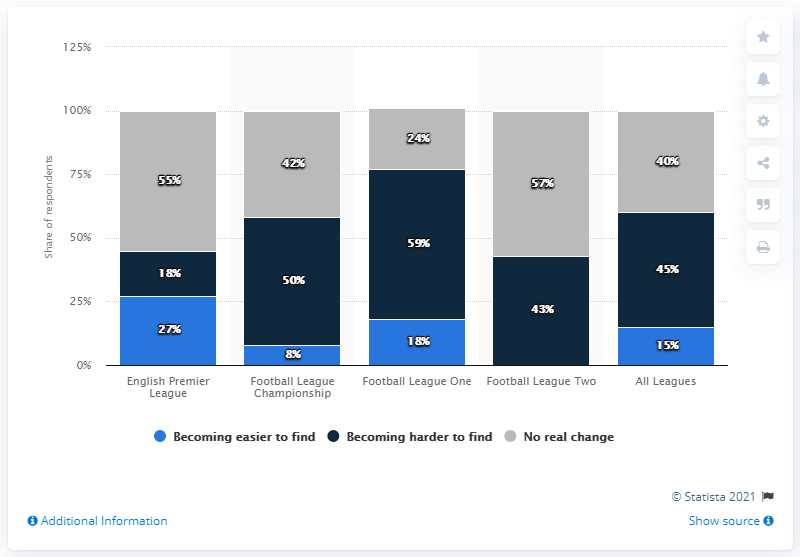Draw attention to some important aspects in this diagram. Out of those who believed there was no significant change in the quality of football played in All Leagues compared to Football League One, 16 were in agreement. The most popular response for all leagues was becoming increasingly difficult to find. 